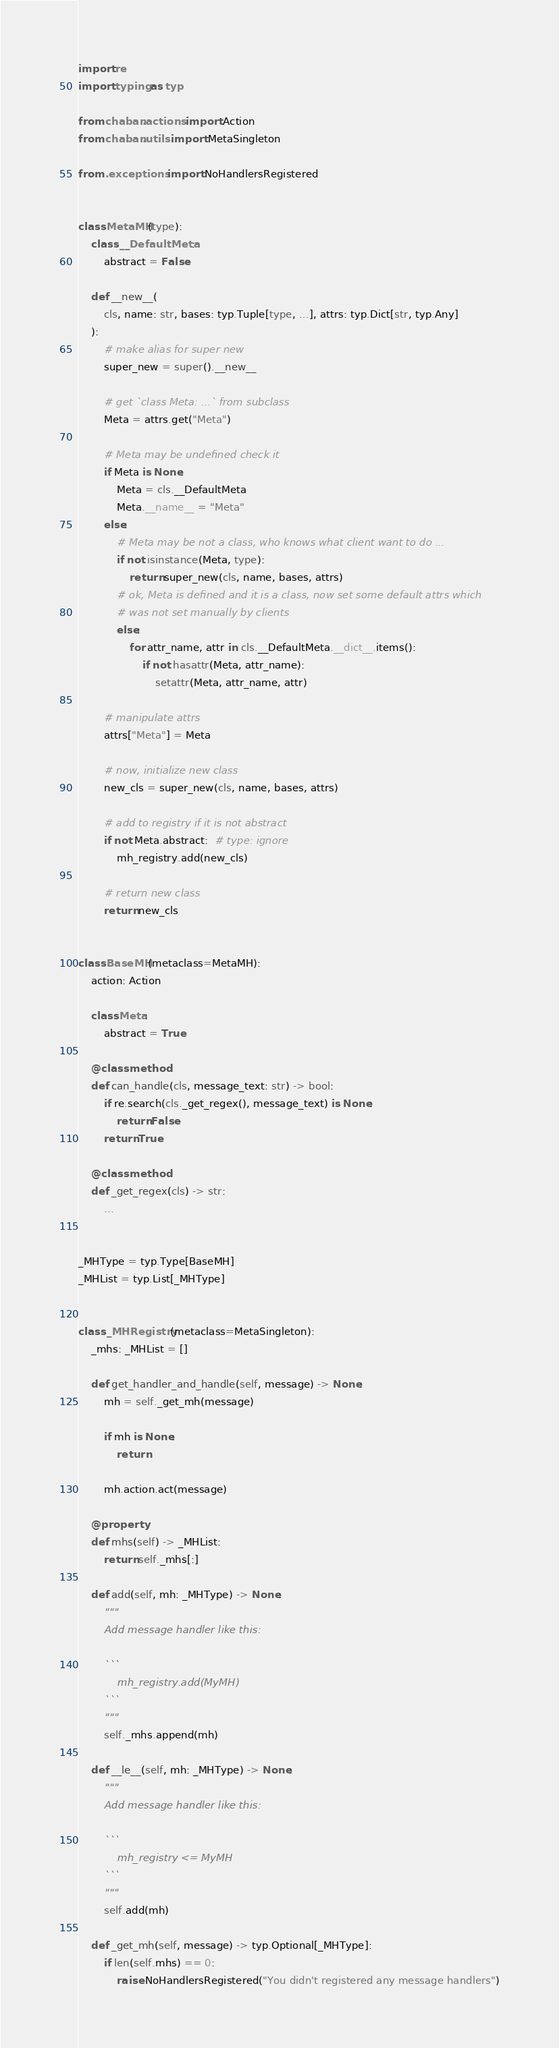<code> <loc_0><loc_0><loc_500><loc_500><_Python_>import re
import typing as typ

from chaban.actions import Action
from chaban.utils import MetaSingleton

from .exceptions import NoHandlersRegistered


class MetaMH(type):
    class __DefaultMeta:
        abstract = False

    def __new__(
        cls, name: str, bases: typ.Tuple[type, ...], attrs: typ.Dict[str, typ.Any]
    ):
        # make alias for super new
        super_new = super().__new__

        # get `class Meta: ...` from subclass
        Meta = attrs.get("Meta")

        # Meta may be undefined check it
        if Meta is None:
            Meta = cls.__DefaultMeta
            Meta.__name__ = "Meta"
        else:
            # Meta may be not a class, who knows what client want to do ...
            if not isinstance(Meta, type):
                return super_new(cls, name, bases, attrs)
            # ok, Meta is defined and it is a class, now set some default attrs which
            # was not set manually by clients
            else:
                for attr_name, attr in cls.__DefaultMeta.__dict__.items():
                    if not hasattr(Meta, attr_name):
                        setattr(Meta, attr_name, attr)

        # manipulate attrs
        attrs["Meta"] = Meta

        # now, initialize new class
        new_cls = super_new(cls, name, bases, attrs)

        # add to registry if it is not abstract
        if not Meta.abstract:  # type: ignore
            mh_registry.add(new_cls)

        # return new class
        return new_cls


class BaseMH(metaclass=MetaMH):
    action: Action

    class Meta:
        abstract = True

    @classmethod
    def can_handle(cls, message_text: str) -> bool:
        if re.search(cls._get_regex(), message_text) is None:
            return False
        return True

    @classmethod
    def _get_regex(cls) -> str:
        ...


_MHType = typ.Type[BaseMH]
_MHList = typ.List[_MHType]


class _MHRegistry(metaclass=MetaSingleton):
    _mhs: _MHList = []

    def get_handler_and_handle(self, message) -> None:
        mh = self._get_mh(message)

        if mh is None:
            return

        mh.action.act(message)

    @property
    def mhs(self) -> _MHList:
        return self._mhs[:]

    def add(self, mh: _MHType) -> None:
        """
        Add message handler like this:

        ```
            mh_registry.add(MyMH)
        ```
        """
        self._mhs.append(mh)

    def __le__(self, mh: _MHType) -> None:
        """
        Add message handler like this:

        ```
            mh_registry <= MyMH
        ```
        """
        self.add(mh)

    def _get_mh(self, message) -> typ.Optional[_MHType]:
        if len(self.mhs) == 0:
            raise NoHandlersRegistered("You didn't registered any message handlers")
</code> 